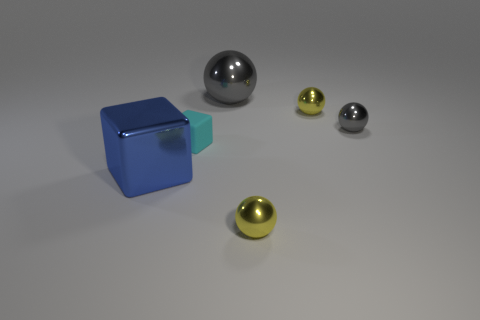Add 2 big blue shiny things. How many objects exist? 8 Subtract all balls. How many objects are left? 2 Add 5 cyan rubber objects. How many cyan rubber objects are left? 6 Add 2 yellow things. How many yellow things exist? 4 Subtract 0 green cylinders. How many objects are left? 6 Subtract all tiny purple balls. Subtract all matte blocks. How many objects are left? 5 